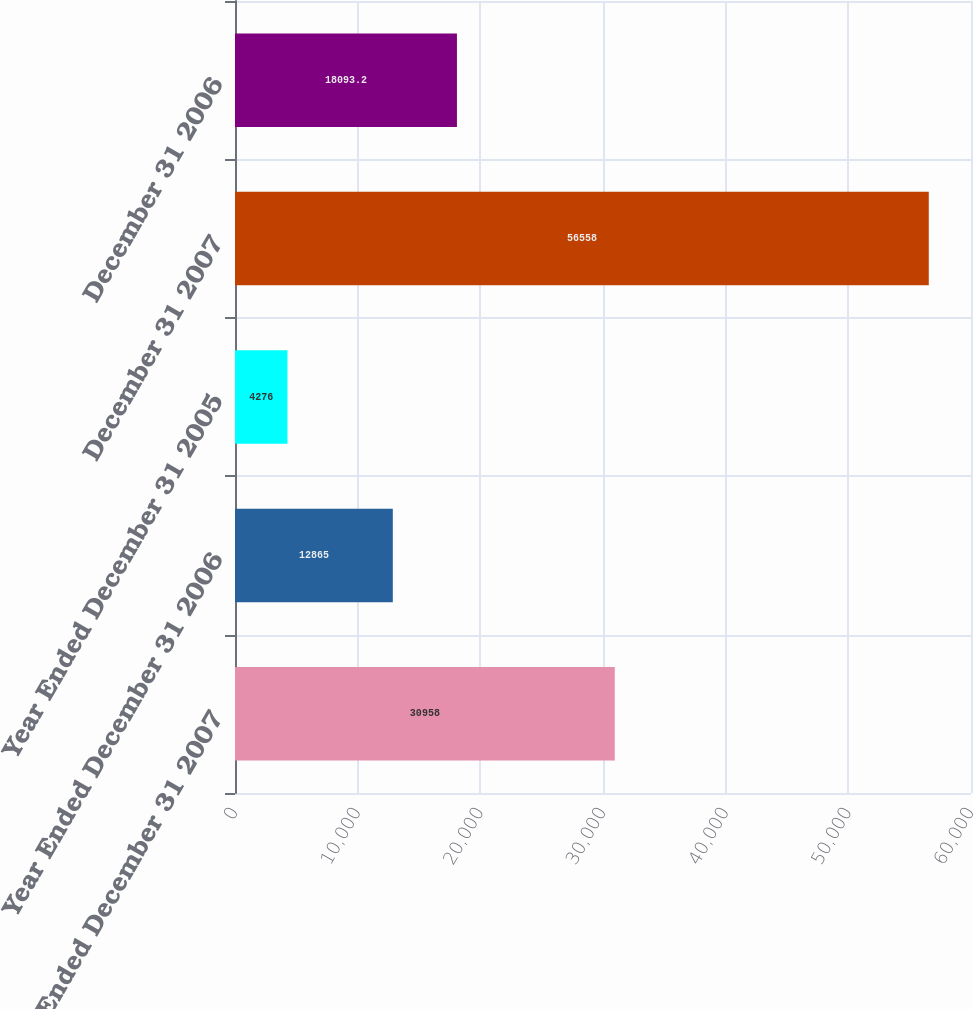<chart> <loc_0><loc_0><loc_500><loc_500><bar_chart><fcel>Year Ended December 31 2007<fcel>Year Ended December 31 2006<fcel>Year Ended December 31 2005<fcel>December 31 2007<fcel>December 31 2006<nl><fcel>30958<fcel>12865<fcel>4276<fcel>56558<fcel>18093.2<nl></chart> 